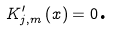<formula> <loc_0><loc_0><loc_500><loc_500>K _ { j , m } ^ { \prime } \left ( x \right ) = 0 \text {.}</formula> 